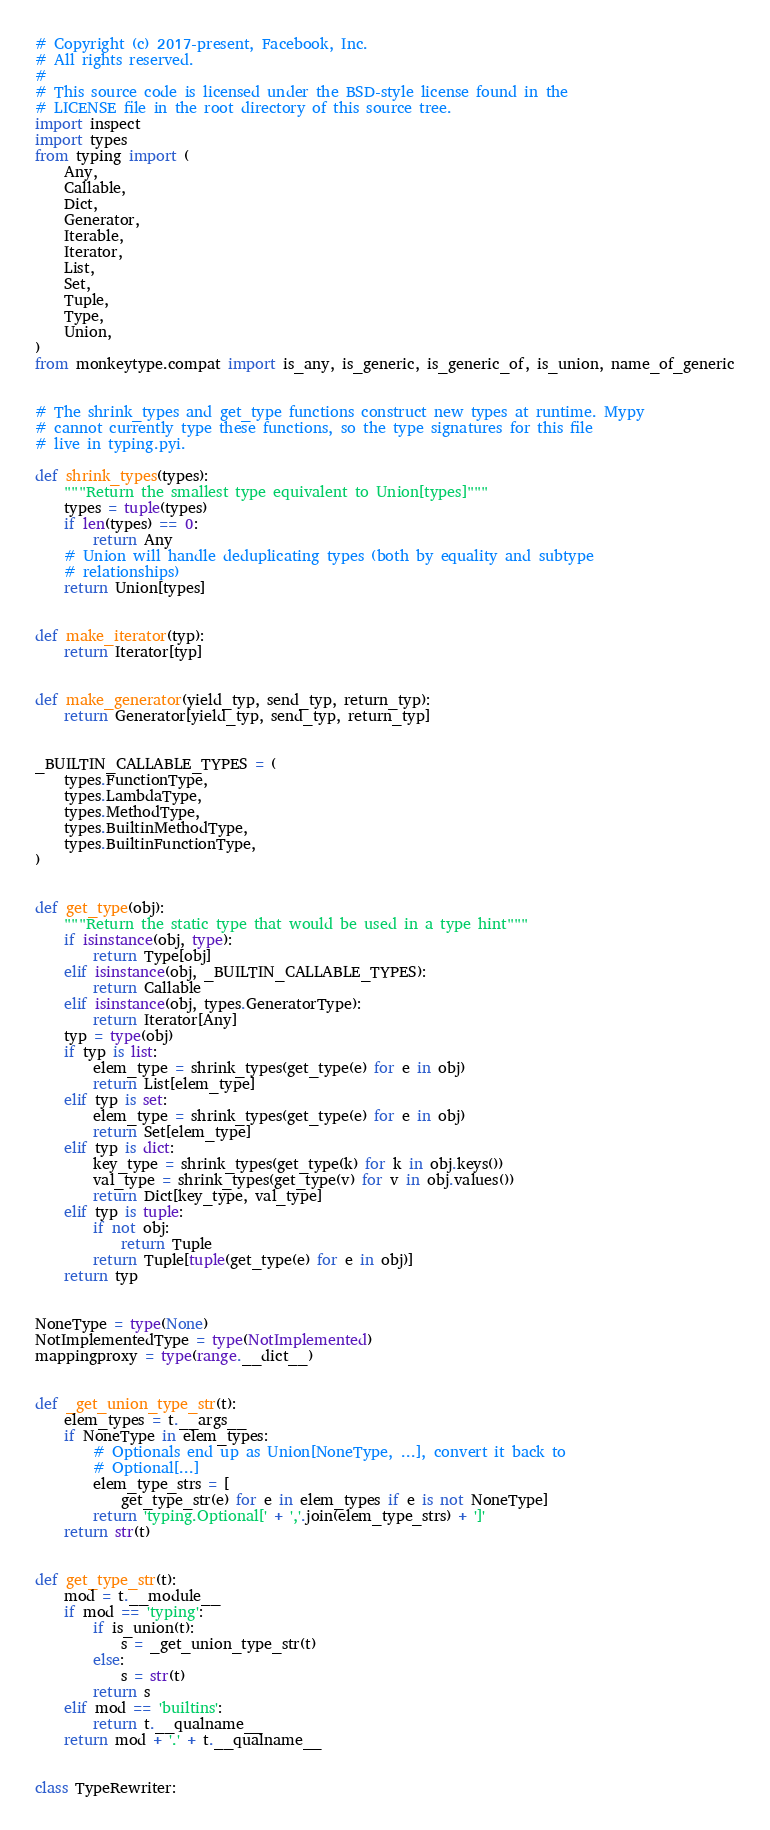Convert code to text. <code><loc_0><loc_0><loc_500><loc_500><_Python_># Copyright (c) 2017-present, Facebook, Inc.
# All rights reserved.
#
# This source code is licensed under the BSD-style license found in the
# LICENSE file in the root directory of this source tree.
import inspect
import types
from typing import (
    Any,
    Callable,
    Dict,
    Generator,
    Iterable,
    Iterator,
    List,
    Set,
    Tuple,
    Type,
    Union,
)
from monkeytype.compat import is_any, is_generic, is_generic_of, is_union, name_of_generic


# The shrink_types and get_type functions construct new types at runtime. Mypy
# cannot currently type these functions, so the type signatures for this file
# live in typing.pyi.

def shrink_types(types):
    """Return the smallest type equivalent to Union[types]"""
    types = tuple(types)
    if len(types) == 0:
        return Any
    # Union will handle deduplicating types (both by equality and subtype
    # relationships)
    return Union[types]


def make_iterator(typ):
    return Iterator[typ]


def make_generator(yield_typ, send_typ, return_typ):
    return Generator[yield_typ, send_typ, return_typ]


_BUILTIN_CALLABLE_TYPES = (
    types.FunctionType,
    types.LambdaType,
    types.MethodType,
    types.BuiltinMethodType,
    types.BuiltinFunctionType,
)


def get_type(obj):
    """Return the static type that would be used in a type hint"""
    if isinstance(obj, type):
        return Type[obj]
    elif isinstance(obj, _BUILTIN_CALLABLE_TYPES):
        return Callable
    elif isinstance(obj, types.GeneratorType):
        return Iterator[Any]
    typ = type(obj)
    if typ is list:
        elem_type = shrink_types(get_type(e) for e in obj)
        return List[elem_type]
    elif typ is set:
        elem_type = shrink_types(get_type(e) for e in obj)
        return Set[elem_type]
    elif typ is dict:
        key_type = shrink_types(get_type(k) for k in obj.keys())
        val_type = shrink_types(get_type(v) for v in obj.values())
        return Dict[key_type, val_type]
    elif typ is tuple:
        if not obj:
            return Tuple
        return Tuple[tuple(get_type(e) for e in obj)]
    return typ


NoneType = type(None)
NotImplementedType = type(NotImplemented)
mappingproxy = type(range.__dict__)


def _get_union_type_str(t):
    elem_types = t.__args__
    if NoneType in elem_types:
        # Optionals end up as Union[NoneType, ...], convert it back to
        # Optional[...]
        elem_type_strs = [
            get_type_str(e) for e in elem_types if e is not NoneType]
        return 'typing.Optional[' + ','.join(elem_type_strs) + ']'
    return str(t)


def get_type_str(t):
    mod = t.__module__
    if mod == 'typing':
        if is_union(t):
            s = _get_union_type_str(t)
        else:
            s = str(t)
        return s
    elif mod == 'builtins':
        return t.__qualname__
    return mod + '.' + t.__qualname__


class TypeRewriter:</code> 